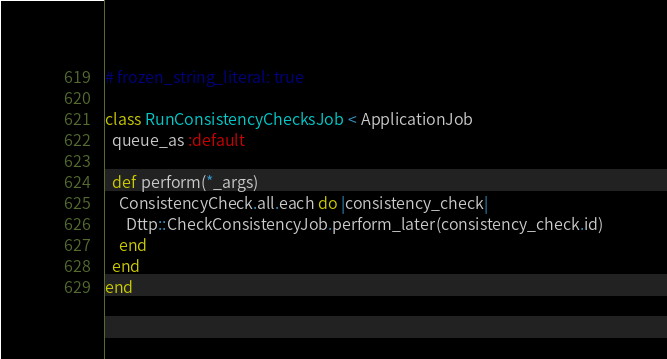<code> <loc_0><loc_0><loc_500><loc_500><_Ruby_># frozen_string_literal: true

class RunConsistencyChecksJob < ApplicationJob
  queue_as :default

  def perform(*_args)
    ConsistencyCheck.all.each do |consistency_check|
      Dttp::CheckConsistencyJob.perform_later(consistency_check.id)
    end
  end
end
</code> 